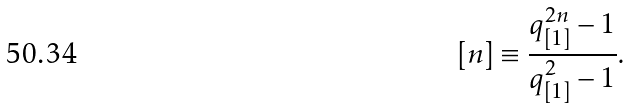<formula> <loc_0><loc_0><loc_500><loc_500>[ n ] \equiv \frac { q _ { [ 1 ] } ^ { 2 n } - 1 } { q _ { [ 1 ] } ^ { 2 } - 1 } .</formula> 